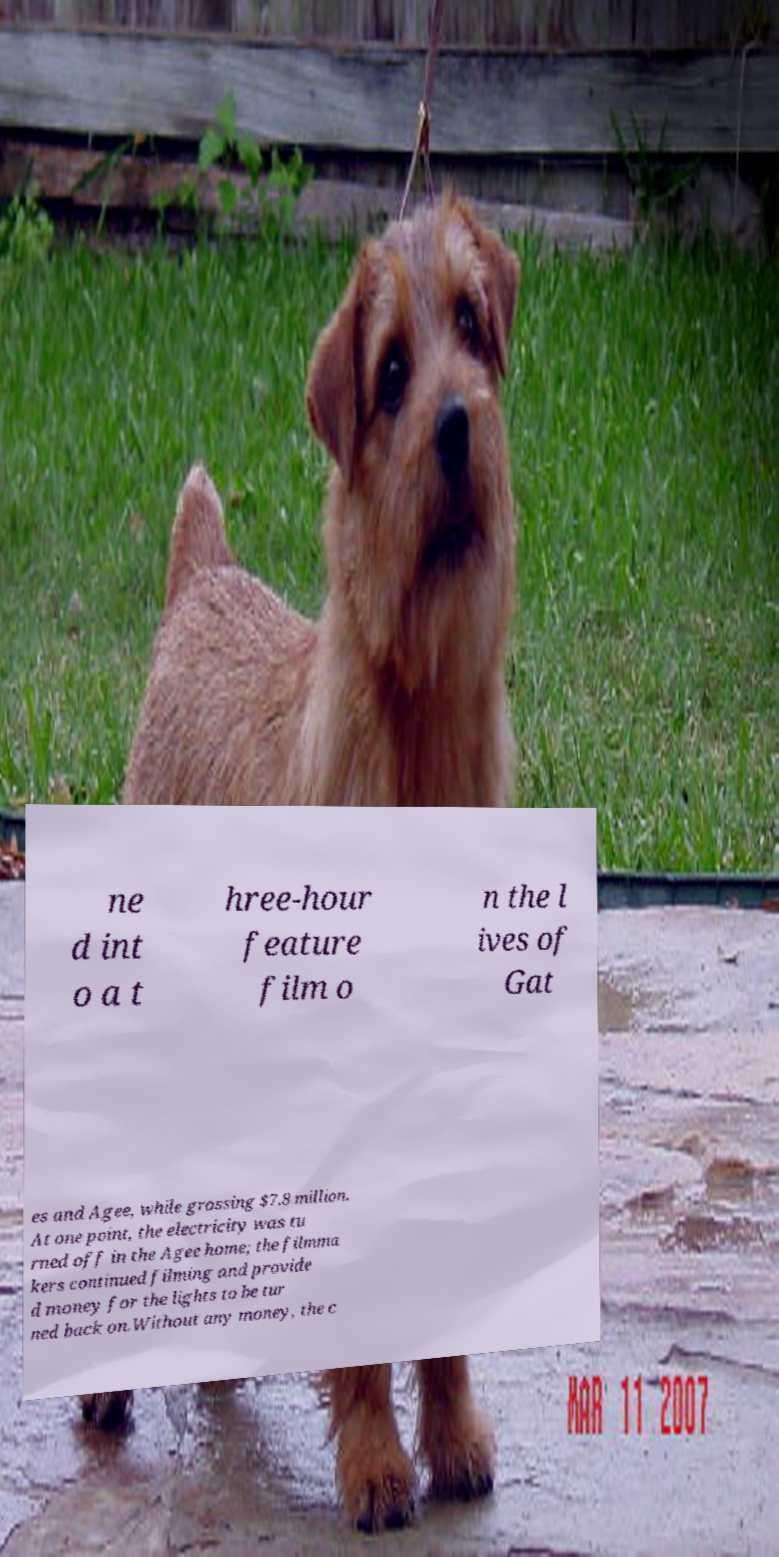What messages or text are displayed in this image? I need them in a readable, typed format. ne d int o a t hree-hour feature film o n the l ives of Gat es and Agee, while grossing $7.8 million. At one point, the electricity was tu rned off in the Agee home; the filmma kers continued filming and provide d money for the lights to be tur ned back on.Without any money, the c 